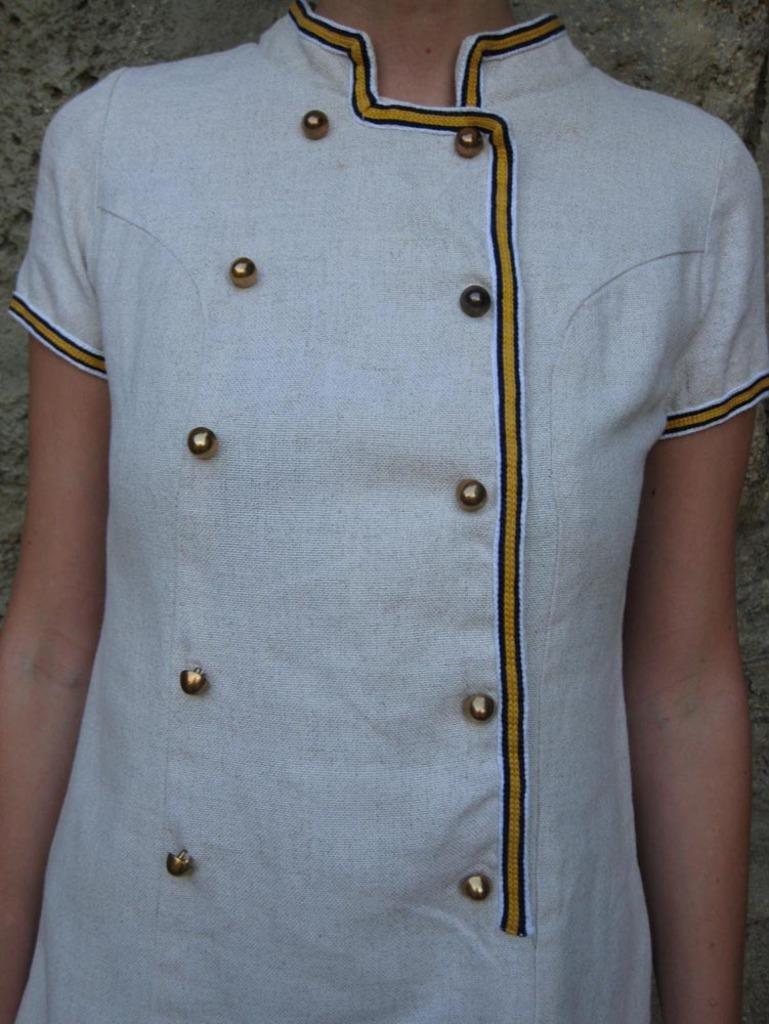Who is the main subject in the image? There is a girl in the image. Where is the girl positioned in the image? The girl is standing in the center of the image. What type of cake is the girl holding in the image? There is no cake present in the image; the girl is not holding anything. 